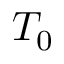Convert formula to latex. <formula><loc_0><loc_0><loc_500><loc_500>T _ { 0 }</formula> 